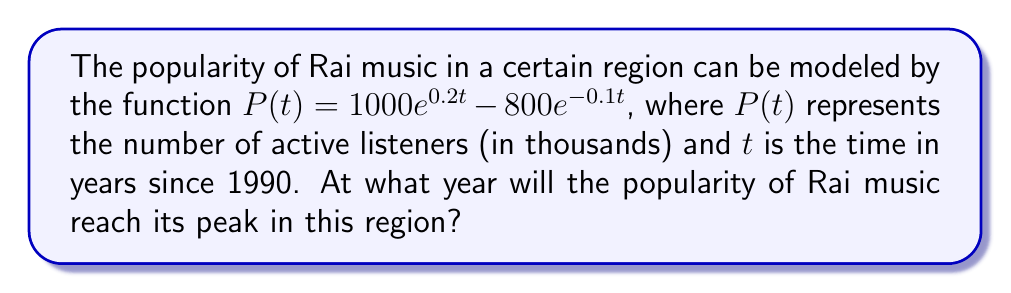What is the answer to this math problem? To find the year when Rai music popularity reaches its peak, we need to follow these steps:

1) First, we need to find the maximum point of the function $P(t)$. This occurs where the derivative $P'(t) = 0$.

2) Let's calculate the derivative:
   $$P'(t) = 1000 \cdot 0.2e^{0.2t} - 800 \cdot (-0.1)e^{-0.1t}$$
   $$P'(t) = 200e^{0.2t} + 80e^{-0.1t}$$

3) Set the derivative equal to zero:
   $$200e^{0.2t} + 80e^{-0.1t} = 0$$

4) Divide both sides by $80e^{-0.1t}$:
   $$2.5e^{0.3t} = -1$$

5) Take the natural log of both sides:
   $$0.3t + \ln(2.5) = \ln(-1)$$

6) Solve for $t$:
   $$t = \frac{\ln(-1) - \ln(2.5)}{0.3}$$

7) The natural log of a negative number is undefined in real numbers, so there is no real solution to this equation.

8) This means that the function doesn't have a maximum point. Instead, it will continue to grow indefinitely.

9) However, the question asks for a year. Since $t$ represents years since 1990, the popularity will continue to grow for the foreseeable future, with no peak within a reasonable timeframe.
Answer: The popularity will continue to grow indefinitely with no peak year. 